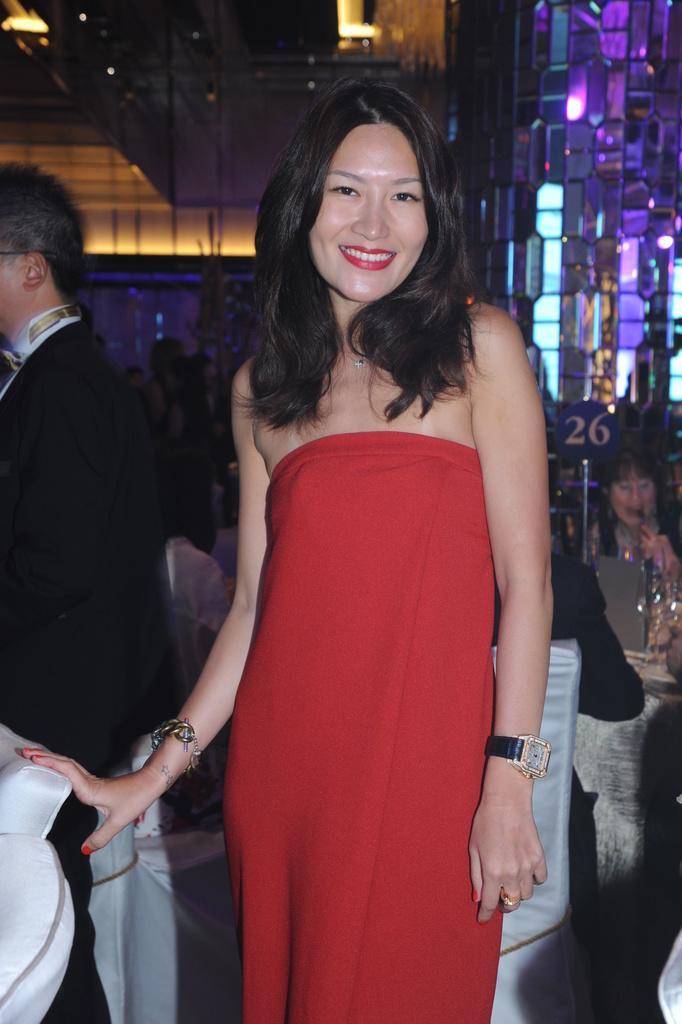Please provide a concise description of this image. In this image I can see the group of people with different color dresses. I can see few people are sitting in-front of the table. On the table I can see the glasses and some objects. In the background there are boards and the buildings. 